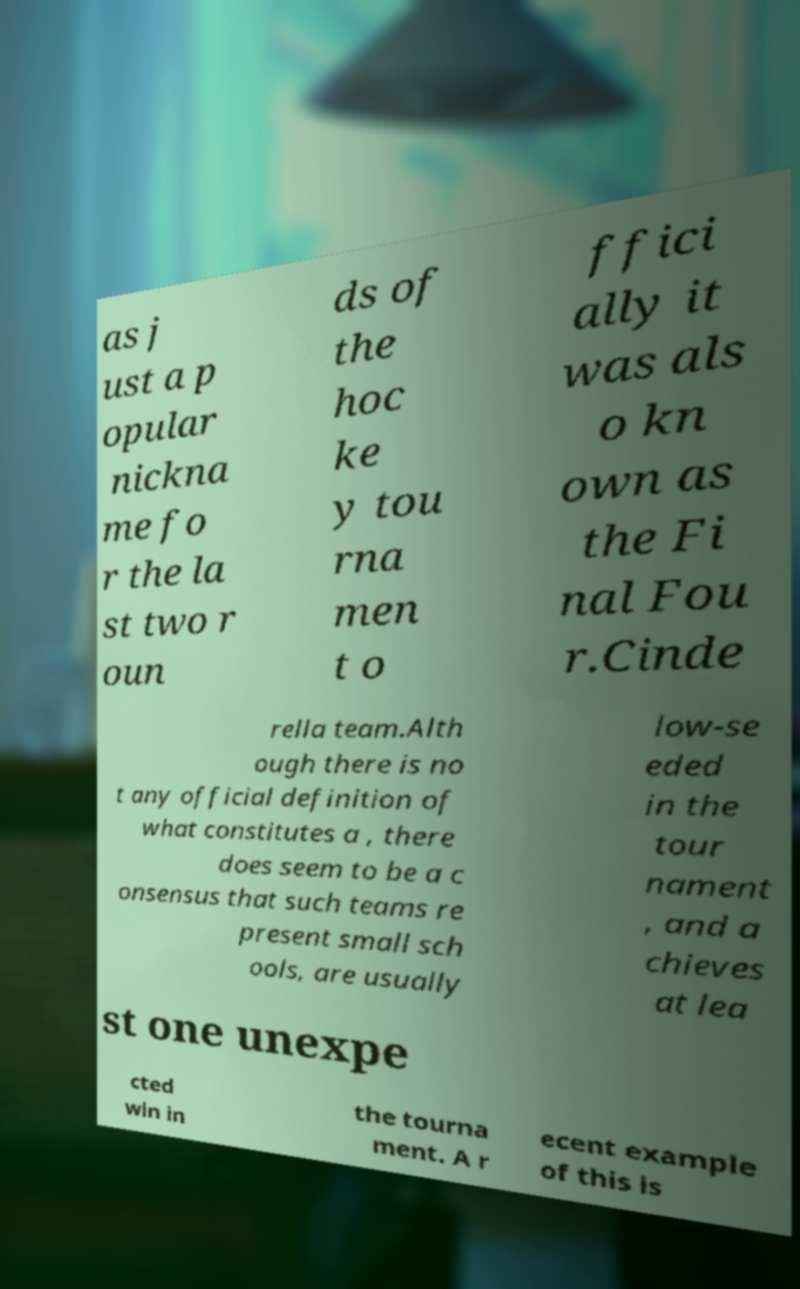I need the written content from this picture converted into text. Can you do that? as j ust a p opular nickna me fo r the la st two r oun ds of the hoc ke y tou rna men t o ffici ally it was als o kn own as the Fi nal Fou r.Cinde rella team.Alth ough there is no t any official definition of what constitutes a , there does seem to be a c onsensus that such teams re present small sch ools, are usually low-se eded in the tour nament , and a chieves at lea st one unexpe cted win in the tourna ment. A r ecent example of this is 